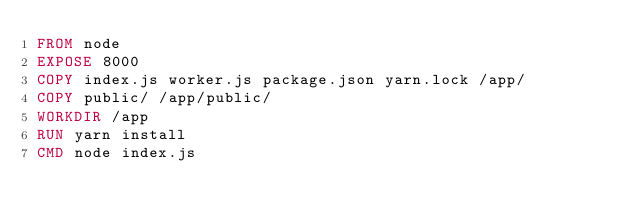<code> <loc_0><loc_0><loc_500><loc_500><_Dockerfile_>FROM node
EXPOSE 8000
COPY index.js worker.js package.json yarn.lock /app/
COPY public/ /app/public/
WORKDIR /app
RUN yarn install
CMD node index.js
</code> 